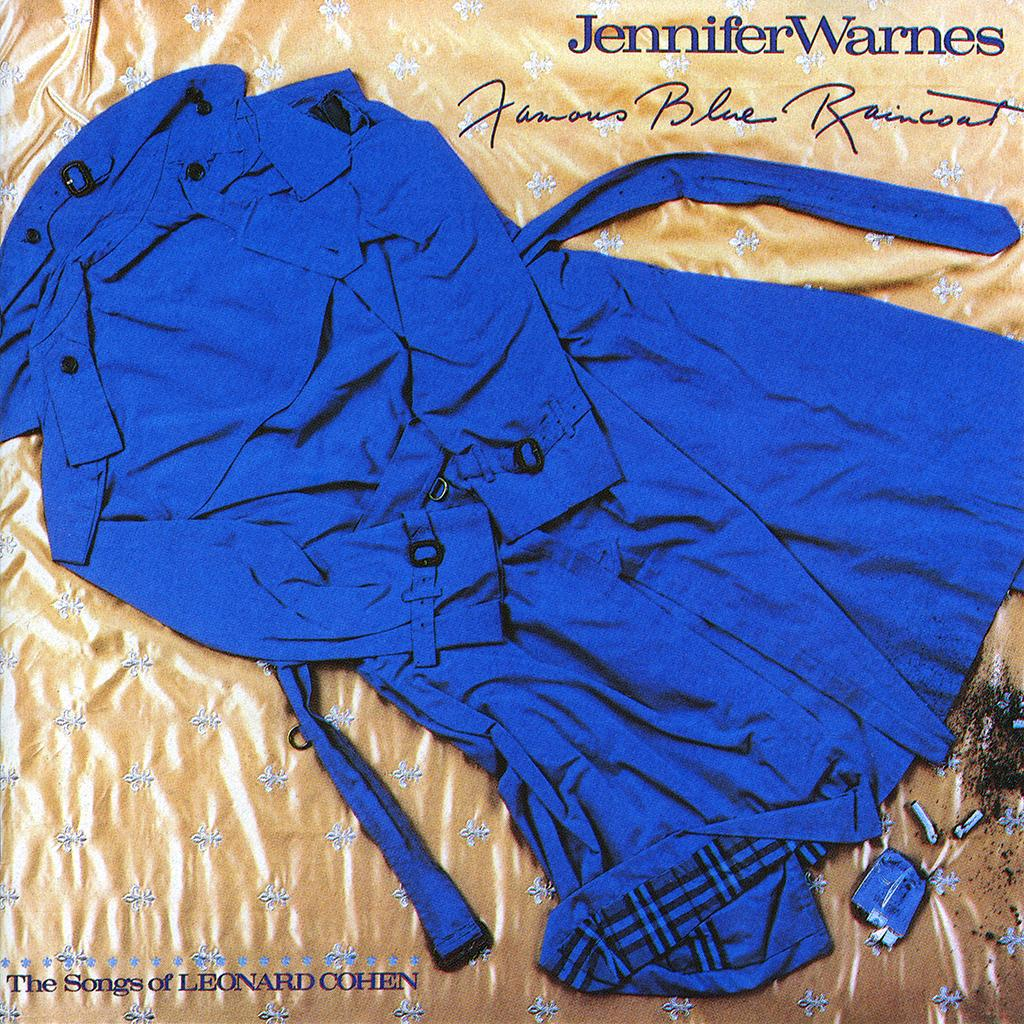What color is the dress in the image? There is a blue color dress in the image. Where is the text located in the image? The text is in the top right corner of the image. What type of fact can be seen blowing in the wind in the image? There is no fact visible in the image, nor is there any wind or blowing object. 